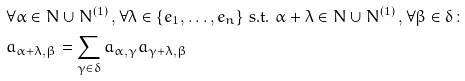<formula> <loc_0><loc_0><loc_500><loc_500>& \forall \alpha \in N \cup N ^ { ( 1 ) } \, , \forall \lambda \in \{ e _ { 1 } , \dots , e _ { n } \} \text { s.t. } \alpha + \lambda \in N \cup N ^ { ( 1 ) } \, , \forall \beta \in \delta \colon \\ & a _ { \alpha + \lambda , \beta } = \sum _ { \gamma \in \delta } a _ { \alpha , \gamma } a _ { \gamma + \lambda , \beta }</formula> 